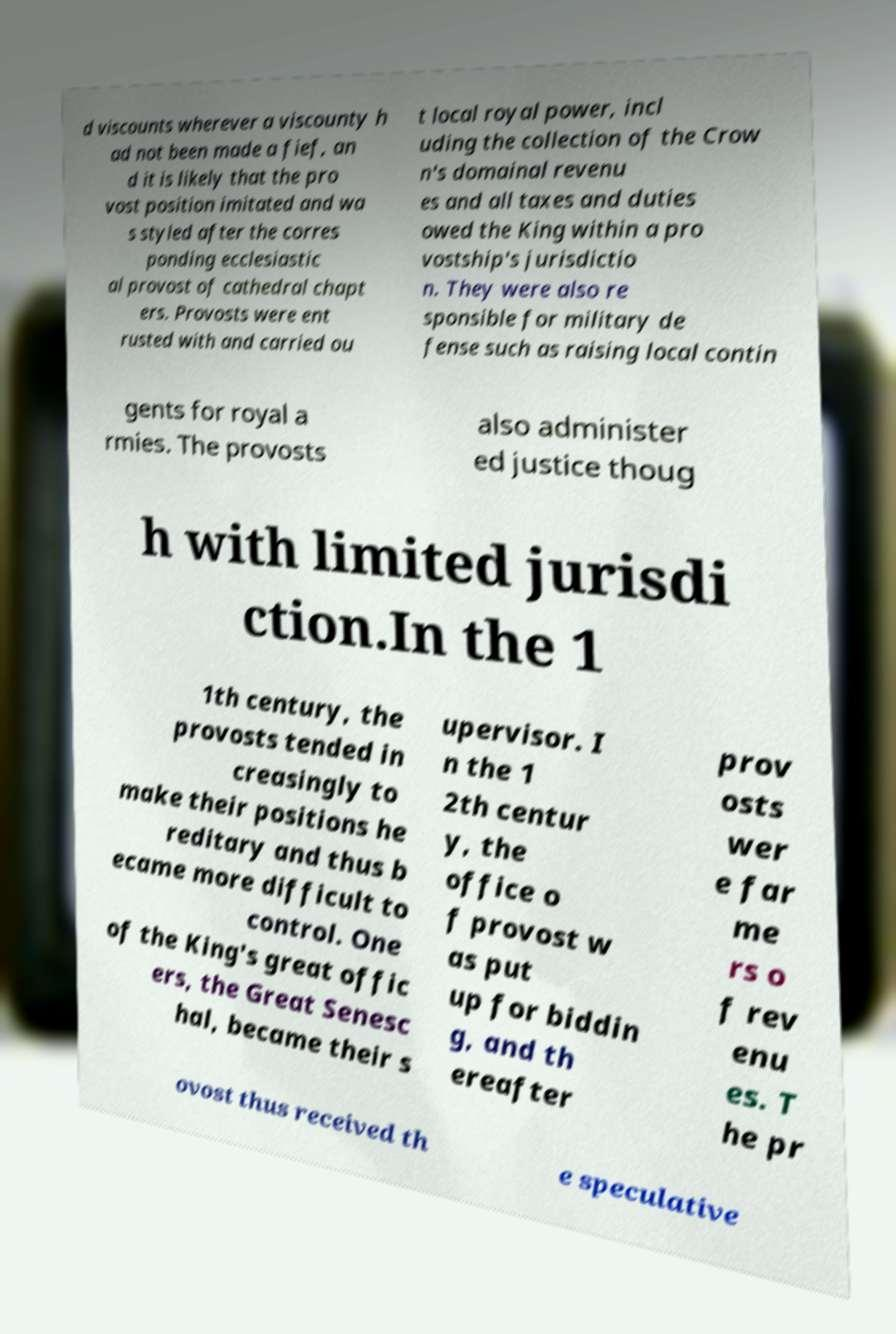I need the written content from this picture converted into text. Can you do that? d viscounts wherever a viscounty h ad not been made a fief, an d it is likely that the pro vost position imitated and wa s styled after the corres ponding ecclesiastic al provost of cathedral chapt ers. Provosts were ent rusted with and carried ou t local royal power, incl uding the collection of the Crow n's domainal revenu es and all taxes and duties owed the King within a pro vostship's jurisdictio n. They were also re sponsible for military de fense such as raising local contin gents for royal a rmies. The provosts also administer ed justice thoug h with limited jurisdi ction.In the 1 1th century, the provosts tended in creasingly to make their positions he reditary and thus b ecame more difficult to control. One of the King's great offic ers, the Great Senesc hal, became their s upervisor. I n the 1 2th centur y, the office o f provost w as put up for biddin g, and th ereafter prov osts wer e far me rs o f rev enu es. T he pr ovost thus received th e speculative 